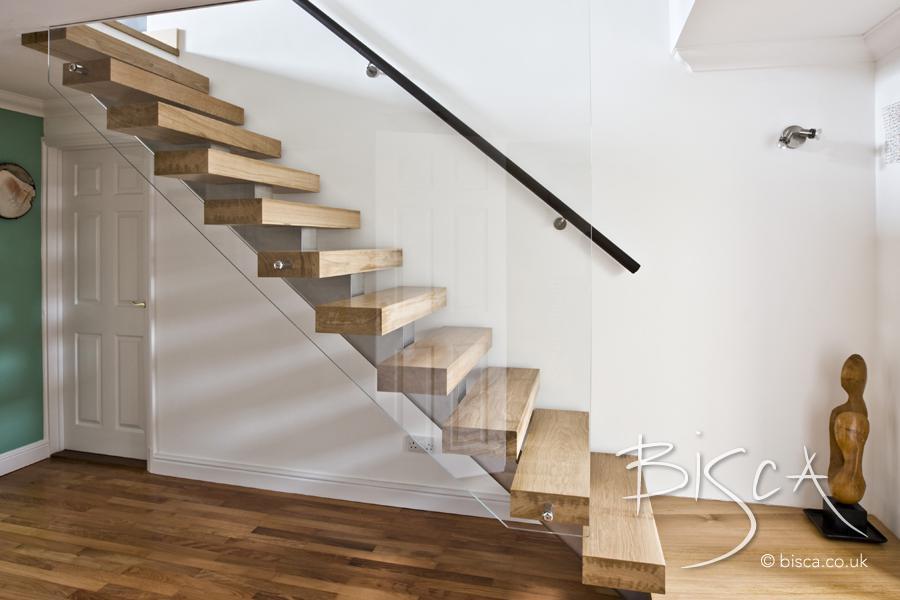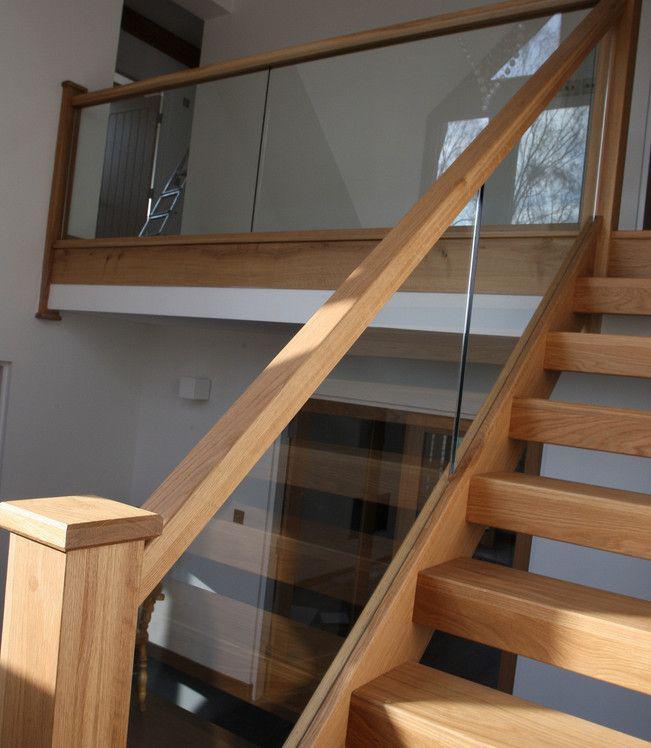The first image is the image on the left, the second image is the image on the right. Given the left and right images, does the statement "In at least one image there is a staircase facing left with three separate glass panels held up by a light brown rail." hold true? Answer yes or no. No. The first image is the image on the left, the second image is the image on the right. Assess this claim about the two images: "Each image shows a staircase that is open underneath and ascends in one diagonal line, without turning and with no upper railed landing.". Correct or not? Answer yes or no. No. 